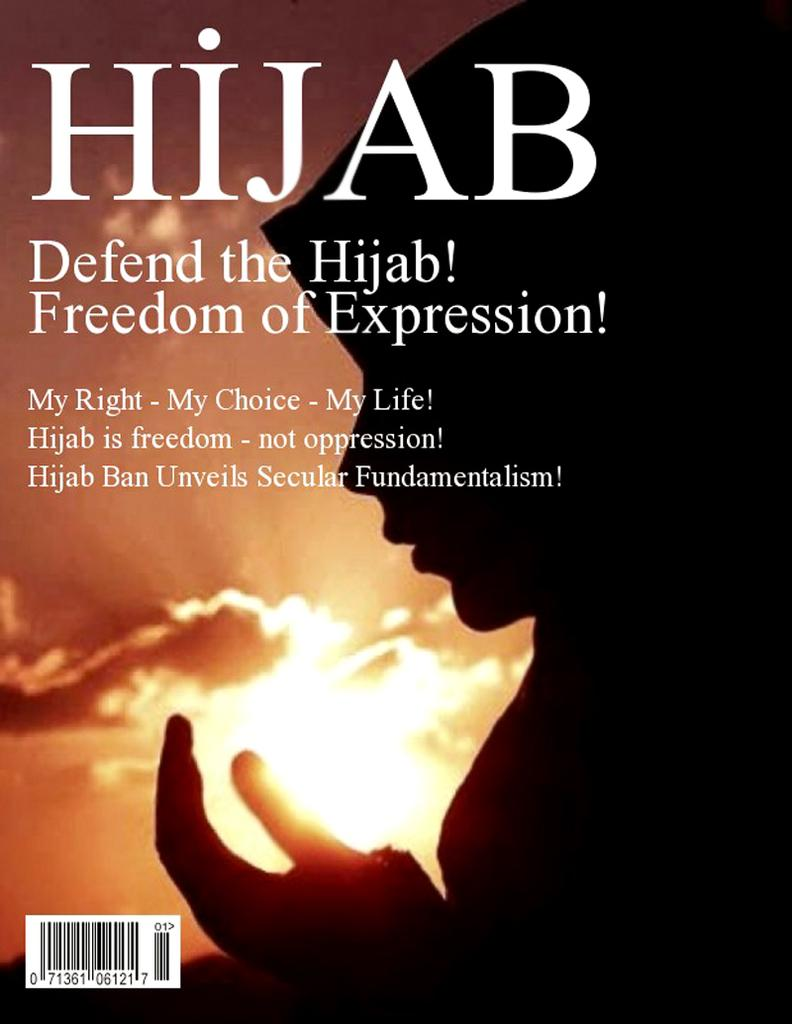Provide a one-sentence caption for the provided image. A book that reads "Defend the Hijab" is on display with a woman wearing a Hijab. 